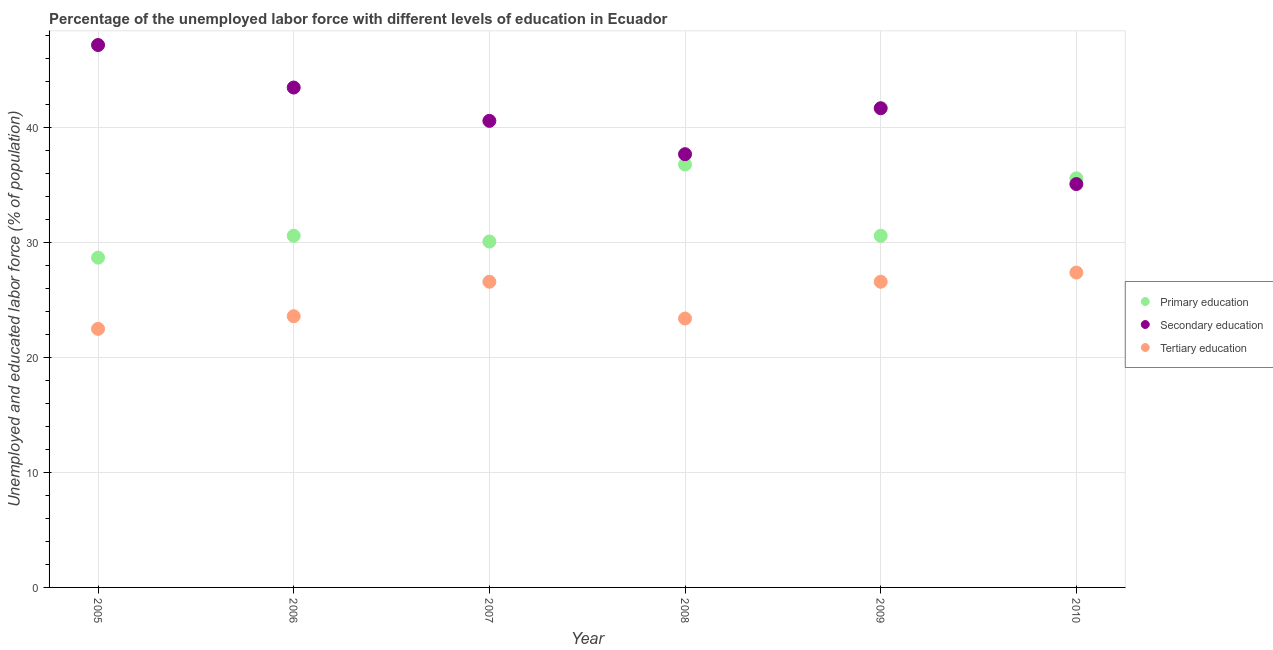Is the number of dotlines equal to the number of legend labels?
Provide a short and direct response. Yes. What is the percentage of labor force who received tertiary education in 2005?
Provide a succinct answer. 22.5. Across all years, what is the maximum percentage of labor force who received tertiary education?
Your response must be concise. 27.4. Across all years, what is the minimum percentage of labor force who received tertiary education?
Provide a short and direct response. 22.5. In which year was the percentage of labor force who received secondary education minimum?
Provide a short and direct response. 2010. What is the total percentage of labor force who received tertiary education in the graph?
Your answer should be very brief. 150.1. What is the difference between the percentage of labor force who received tertiary education in 2005 and that in 2008?
Provide a short and direct response. -0.9. What is the difference between the percentage of labor force who received primary education in 2006 and the percentage of labor force who received tertiary education in 2005?
Provide a succinct answer. 8.1. What is the average percentage of labor force who received tertiary education per year?
Offer a terse response. 25.02. In the year 2010, what is the difference between the percentage of labor force who received tertiary education and percentage of labor force who received primary education?
Provide a short and direct response. -8.2. In how many years, is the percentage of labor force who received tertiary education greater than 6 %?
Give a very brief answer. 6. What is the ratio of the percentage of labor force who received tertiary education in 2007 to that in 2010?
Your answer should be compact. 0.97. Is the percentage of labor force who received tertiary education in 2007 less than that in 2008?
Ensure brevity in your answer.  No. What is the difference between the highest and the second highest percentage of labor force who received tertiary education?
Make the answer very short. 0.8. What is the difference between the highest and the lowest percentage of labor force who received tertiary education?
Your response must be concise. 4.9. Is the sum of the percentage of labor force who received secondary education in 2007 and 2010 greater than the maximum percentage of labor force who received primary education across all years?
Provide a short and direct response. Yes. Is the percentage of labor force who received tertiary education strictly less than the percentage of labor force who received secondary education over the years?
Your answer should be very brief. Yes. What is the difference between two consecutive major ticks on the Y-axis?
Make the answer very short. 10. Are the values on the major ticks of Y-axis written in scientific E-notation?
Offer a very short reply. No. Does the graph contain any zero values?
Your answer should be very brief. No. Where does the legend appear in the graph?
Give a very brief answer. Center right. What is the title of the graph?
Your response must be concise. Percentage of the unemployed labor force with different levels of education in Ecuador. What is the label or title of the X-axis?
Ensure brevity in your answer.  Year. What is the label or title of the Y-axis?
Make the answer very short. Unemployed and educated labor force (% of population). What is the Unemployed and educated labor force (% of population) of Primary education in 2005?
Keep it short and to the point. 28.7. What is the Unemployed and educated labor force (% of population) of Secondary education in 2005?
Provide a succinct answer. 47.2. What is the Unemployed and educated labor force (% of population) in Tertiary education in 2005?
Ensure brevity in your answer.  22.5. What is the Unemployed and educated labor force (% of population) of Primary education in 2006?
Your answer should be very brief. 30.6. What is the Unemployed and educated labor force (% of population) in Secondary education in 2006?
Ensure brevity in your answer.  43.5. What is the Unemployed and educated labor force (% of population) in Tertiary education in 2006?
Provide a short and direct response. 23.6. What is the Unemployed and educated labor force (% of population) of Primary education in 2007?
Offer a terse response. 30.1. What is the Unemployed and educated labor force (% of population) of Secondary education in 2007?
Offer a terse response. 40.6. What is the Unemployed and educated labor force (% of population) in Tertiary education in 2007?
Offer a very short reply. 26.6. What is the Unemployed and educated labor force (% of population) in Primary education in 2008?
Your answer should be compact. 36.8. What is the Unemployed and educated labor force (% of population) of Secondary education in 2008?
Give a very brief answer. 37.7. What is the Unemployed and educated labor force (% of population) in Tertiary education in 2008?
Offer a terse response. 23.4. What is the Unemployed and educated labor force (% of population) of Primary education in 2009?
Provide a succinct answer. 30.6. What is the Unemployed and educated labor force (% of population) of Secondary education in 2009?
Your answer should be very brief. 41.7. What is the Unemployed and educated labor force (% of population) of Tertiary education in 2009?
Your answer should be very brief. 26.6. What is the Unemployed and educated labor force (% of population) in Primary education in 2010?
Offer a very short reply. 35.6. What is the Unemployed and educated labor force (% of population) of Secondary education in 2010?
Your answer should be compact. 35.1. What is the Unemployed and educated labor force (% of population) of Tertiary education in 2010?
Give a very brief answer. 27.4. Across all years, what is the maximum Unemployed and educated labor force (% of population) in Primary education?
Offer a terse response. 36.8. Across all years, what is the maximum Unemployed and educated labor force (% of population) in Secondary education?
Provide a short and direct response. 47.2. Across all years, what is the maximum Unemployed and educated labor force (% of population) in Tertiary education?
Provide a short and direct response. 27.4. Across all years, what is the minimum Unemployed and educated labor force (% of population) of Primary education?
Your answer should be very brief. 28.7. Across all years, what is the minimum Unemployed and educated labor force (% of population) in Secondary education?
Make the answer very short. 35.1. Across all years, what is the minimum Unemployed and educated labor force (% of population) in Tertiary education?
Keep it short and to the point. 22.5. What is the total Unemployed and educated labor force (% of population) of Primary education in the graph?
Offer a very short reply. 192.4. What is the total Unemployed and educated labor force (% of population) in Secondary education in the graph?
Offer a terse response. 245.8. What is the total Unemployed and educated labor force (% of population) in Tertiary education in the graph?
Provide a short and direct response. 150.1. What is the difference between the Unemployed and educated labor force (% of population) in Primary education in 2005 and that in 2006?
Offer a very short reply. -1.9. What is the difference between the Unemployed and educated labor force (% of population) in Secondary education in 2005 and that in 2007?
Keep it short and to the point. 6.6. What is the difference between the Unemployed and educated labor force (% of population) of Tertiary education in 2005 and that in 2007?
Your answer should be very brief. -4.1. What is the difference between the Unemployed and educated labor force (% of population) in Primary education in 2005 and that in 2008?
Offer a terse response. -8.1. What is the difference between the Unemployed and educated labor force (% of population) of Secondary education in 2005 and that in 2008?
Make the answer very short. 9.5. What is the difference between the Unemployed and educated labor force (% of population) of Tertiary education in 2005 and that in 2008?
Offer a very short reply. -0.9. What is the difference between the Unemployed and educated labor force (% of population) in Primary education in 2005 and that in 2009?
Offer a very short reply. -1.9. What is the difference between the Unemployed and educated labor force (% of population) of Tertiary education in 2005 and that in 2009?
Your response must be concise. -4.1. What is the difference between the Unemployed and educated labor force (% of population) in Primary education in 2005 and that in 2010?
Give a very brief answer. -6.9. What is the difference between the Unemployed and educated labor force (% of population) of Secondary education in 2005 and that in 2010?
Provide a succinct answer. 12.1. What is the difference between the Unemployed and educated labor force (% of population) in Primary education in 2006 and that in 2007?
Your answer should be very brief. 0.5. What is the difference between the Unemployed and educated labor force (% of population) of Secondary education in 2006 and that in 2007?
Offer a terse response. 2.9. What is the difference between the Unemployed and educated labor force (% of population) of Tertiary education in 2006 and that in 2007?
Provide a short and direct response. -3. What is the difference between the Unemployed and educated labor force (% of population) of Primary education in 2006 and that in 2008?
Provide a short and direct response. -6.2. What is the difference between the Unemployed and educated labor force (% of population) of Secondary education in 2006 and that in 2009?
Your answer should be very brief. 1.8. What is the difference between the Unemployed and educated labor force (% of population) of Primary education in 2006 and that in 2010?
Offer a very short reply. -5. What is the difference between the Unemployed and educated labor force (% of population) of Tertiary education in 2006 and that in 2010?
Your answer should be very brief. -3.8. What is the difference between the Unemployed and educated labor force (% of population) in Primary education in 2007 and that in 2008?
Your response must be concise. -6.7. What is the difference between the Unemployed and educated labor force (% of population) in Primary education in 2007 and that in 2010?
Your response must be concise. -5.5. What is the difference between the Unemployed and educated labor force (% of population) of Secondary education in 2007 and that in 2010?
Provide a succinct answer. 5.5. What is the difference between the Unemployed and educated labor force (% of population) of Primary education in 2008 and that in 2009?
Ensure brevity in your answer.  6.2. What is the difference between the Unemployed and educated labor force (% of population) of Secondary education in 2008 and that in 2009?
Provide a succinct answer. -4. What is the difference between the Unemployed and educated labor force (% of population) in Tertiary education in 2008 and that in 2009?
Your response must be concise. -3.2. What is the difference between the Unemployed and educated labor force (% of population) of Primary education in 2009 and that in 2010?
Keep it short and to the point. -5. What is the difference between the Unemployed and educated labor force (% of population) in Tertiary education in 2009 and that in 2010?
Offer a very short reply. -0.8. What is the difference between the Unemployed and educated labor force (% of population) in Primary education in 2005 and the Unemployed and educated labor force (% of population) in Secondary education in 2006?
Ensure brevity in your answer.  -14.8. What is the difference between the Unemployed and educated labor force (% of population) of Primary education in 2005 and the Unemployed and educated labor force (% of population) of Tertiary education in 2006?
Provide a succinct answer. 5.1. What is the difference between the Unemployed and educated labor force (% of population) in Secondary education in 2005 and the Unemployed and educated labor force (% of population) in Tertiary education in 2006?
Provide a short and direct response. 23.6. What is the difference between the Unemployed and educated labor force (% of population) in Primary education in 2005 and the Unemployed and educated labor force (% of population) in Secondary education in 2007?
Offer a very short reply. -11.9. What is the difference between the Unemployed and educated labor force (% of population) of Primary education in 2005 and the Unemployed and educated labor force (% of population) of Tertiary education in 2007?
Your response must be concise. 2.1. What is the difference between the Unemployed and educated labor force (% of population) in Secondary education in 2005 and the Unemployed and educated labor force (% of population) in Tertiary education in 2007?
Provide a succinct answer. 20.6. What is the difference between the Unemployed and educated labor force (% of population) of Primary education in 2005 and the Unemployed and educated labor force (% of population) of Secondary education in 2008?
Offer a very short reply. -9. What is the difference between the Unemployed and educated labor force (% of population) of Secondary education in 2005 and the Unemployed and educated labor force (% of population) of Tertiary education in 2008?
Give a very brief answer. 23.8. What is the difference between the Unemployed and educated labor force (% of population) in Secondary education in 2005 and the Unemployed and educated labor force (% of population) in Tertiary education in 2009?
Give a very brief answer. 20.6. What is the difference between the Unemployed and educated labor force (% of population) of Primary education in 2005 and the Unemployed and educated labor force (% of population) of Tertiary education in 2010?
Your response must be concise. 1.3. What is the difference between the Unemployed and educated labor force (% of population) of Secondary education in 2005 and the Unemployed and educated labor force (% of population) of Tertiary education in 2010?
Provide a succinct answer. 19.8. What is the difference between the Unemployed and educated labor force (% of population) of Primary education in 2006 and the Unemployed and educated labor force (% of population) of Secondary education in 2007?
Offer a terse response. -10. What is the difference between the Unemployed and educated labor force (% of population) in Primary education in 2006 and the Unemployed and educated labor force (% of population) in Secondary education in 2008?
Offer a very short reply. -7.1. What is the difference between the Unemployed and educated labor force (% of population) in Secondary education in 2006 and the Unemployed and educated labor force (% of population) in Tertiary education in 2008?
Make the answer very short. 20.1. What is the difference between the Unemployed and educated labor force (% of population) in Secondary education in 2006 and the Unemployed and educated labor force (% of population) in Tertiary education in 2009?
Provide a short and direct response. 16.9. What is the difference between the Unemployed and educated labor force (% of population) in Secondary education in 2006 and the Unemployed and educated labor force (% of population) in Tertiary education in 2010?
Provide a succinct answer. 16.1. What is the difference between the Unemployed and educated labor force (% of population) in Secondary education in 2007 and the Unemployed and educated labor force (% of population) in Tertiary education in 2008?
Offer a terse response. 17.2. What is the difference between the Unemployed and educated labor force (% of population) in Primary education in 2007 and the Unemployed and educated labor force (% of population) in Secondary education in 2009?
Offer a terse response. -11.6. What is the difference between the Unemployed and educated labor force (% of population) in Primary education in 2007 and the Unemployed and educated labor force (% of population) in Tertiary education in 2009?
Your response must be concise. 3.5. What is the difference between the Unemployed and educated labor force (% of population) in Secondary education in 2007 and the Unemployed and educated labor force (% of population) in Tertiary education in 2009?
Provide a succinct answer. 14. What is the difference between the Unemployed and educated labor force (% of population) of Primary education in 2007 and the Unemployed and educated labor force (% of population) of Secondary education in 2010?
Make the answer very short. -5. What is the difference between the Unemployed and educated labor force (% of population) of Primary education in 2008 and the Unemployed and educated labor force (% of population) of Secondary education in 2009?
Your answer should be very brief. -4.9. What is the difference between the Unemployed and educated labor force (% of population) in Primary education in 2008 and the Unemployed and educated labor force (% of population) in Tertiary education in 2009?
Keep it short and to the point. 10.2. What is the difference between the Unemployed and educated labor force (% of population) of Primary education in 2008 and the Unemployed and educated labor force (% of population) of Tertiary education in 2010?
Offer a terse response. 9.4. What is the difference between the Unemployed and educated labor force (% of population) of Primary education in 2009 and the Unemployed and educated labor force (% of population) of Tertiary education in 2010?
Keep it short and to the point. 3.2. What is the average Unemployed and educated labor force (% of population) in Primary education per year?
Your answer should be compact. 32.07. What is the average Unemployed and educated labor force (% of population) of Secondary education per year?
Your answer should be very brief. 40.97. What is the average Unemployed and educated labor force (% of population) in Tertiary education per year?
Keep it short and to the point. 25.02. In the year 2005, what is the difference between the Unemployed and educated labor force (% of population) in Primary education and Unemployed and educated labor force (% of population) in Secondary education?
Ensure brevity in your answer.  -18.5. In the year 2005, what is the difference between the Unemployed and educated labor force (% of population) in Secondary education and Unemployed and educated labor force (% of population) in Tertiary education?
Your response must be concise. 24.7. In the year 2007, what is the difference between the Unemployed and educated labor force (% of population) of Primary education and Unemployed and educated labor force (% of population) of Secondary education?
Your response must be concise. -10.5. In the year 2007, what is the difference between the Unemployed and educated labor force (% of population) of Primary education and Unemployed and educated labor force (% of population) of Tertiary education?
Give a very brief answer. 3.5. In the year 2008, what is the difference between the Unemployed and educated labor force (% of population) of Primary education and Unemployed and educated labor force (% of population) of Tertiary education?
Ensure brevity in your answer.  13.4. In the year 2008, what is the difference between the Unemployed and educated labor force (% of population) of Secondary education and Unemployed and educated labor force (% of population) of Tertiary education?
Offer a terse response. 14.3. In the year 2009, what is the difference between the Unemployed and educated labor force (% of population) in Primary education and Unemployed and educated labor force (% of population) in Secondary education?
Provide a succinct answer. -11.1. In the year 2009, what is the difference between the Unemployed and educated labor force (% of population) of Secondary education and Unemployed and educated labor force (% of population) of Tertiary education?
Make the answer very short. 15.1. In the year 2010, what is the difference between the Unemployed and educated labor force (% of population) of Primary education and Unemployed and educated labor force (% of population) of Tertiary education?
Ensure brevity in your answer.  8.2. What is the ratio of the Unemployed and educated labor force (% of population) in Primary education in 2005 to that in 2006?
Keep it short and to the point. 0.94. What is the ratio of the Unemployed and educated labor force (% of population) of Secondary education in 2005 to that in 2006?
Ensure brevity in your answer.  1.09. What is the ratio of the Unemployed and educated labor force (% of population) in Tertiary education in 2005 to that in 2006?
Your answer should be very brief. 0.95. What is the ratio of the Unemployed and educated labor force (% of population) in Primary education in 2005 to that in 2007?
Offer a terse response. 0.95. What is the ratio of the Unemployed and educated labor force (% of population) in Secondary education in 2005 to that in 2007?
Your answer should be compact. 1.16. What is the ratio of the Unemployed and educated labor force (% of population) of Tertiary education in 2005 to that in 2007?
Your response must be concise. 0.85. What is the ratio of the Unemployed and educated labor force (% of population) of Primary education in 2005 to that in 2008?
Provide a short and direct response. 0.78. What is the ratio of the Unemployed and educated labor force (% of population) of Secondary education in 2005 to that in 2008?
Give a very brief answer. 1.25. What is the ratio of the Unemployed and educated labor force (% of population) of Tertiary education in 2005 to that in 2008?
Provide a short and direct response. 0.96. What is the ratio of the Unemployed and educated labor force (% of population) in Primary education in 2005 to that in 2009?
Offer a terse response. 0.94. What is the ratio of the Unemployed and educated labor force (% of population) in Secondary education in 2005 to that in 2009?
Offer a terse response. 1.13. What is the ratio of the Unemployed and educated labor force (% of population) of Tertiary education in 2005 to that in 2009?
Offer a very short reply. 0.85. What is the ratio of the Unemployed and educated labor force (% of population) of Primary education in 2005 to that in 2010?
Offer a very short reply. 0.81. What is the ratio of the Unemployed and educated labor force (% of population) in Secondary education in 2005 to that in 2010?
Your response must be concise. 1.34. What is the ratio of the Unemployed and educated labor force (% of population) of Tertiary education in 2005 to that in 2010?
Your response must be concise. 0.82. What is the ratio of the Unemployed and educated labor force (% of population) in Primary education in 2006 to that in 2007?
Offer a terse response. 1.02. What is the ratio of the Unemployed and educated labor force (% of population) in Secondary education in 2006 to that in 2007?
Your answer should be very brief. 1.07. What is the ratio of the Unemployed and educated labor force (% of population) of Tertiary education in 2006 to that in 2007?
Make the answer very short. 0.89. What is the ratio of the Unemployed and educated labor force (% of population) in Primary education in 2006 to that in 2008?
Offer a very short reply. 0.83. What is the ratio of the Unemployed and educated labor force (% of population) of Secondary education in 2006 to that in 2008?
Ensure brevity in your answer.  1.15. What is the ratio of the Unemployed and educated labor force (% of population) of Tertiary education in 2006 to that in 2008?
Provide a short and direct response. 1.01. What is the ratio of the Unemployed and educated labor force (% of population) in Primary education in 2006 to that in 2009?
Provide a succinct answer. 1. What is the ratio of the Unemployed and educated labor force (% of population) in Secondary education in 2006 to that in 2009?
Your answer should be compact. 1.04. What is the ratio of the Unemployed and educated labor force (% of population) in Tertiary education in 2006 to that in 2009?
Provide a succinct answer. 0.89. What is the ratio of the Unemployed and educated labor force (% of population) of Primary education in 2006 to that in 2010?
Your response must be concise. 0.86. What is the ratio of the Unemployed and educated labor force (% of population) of Secondary education in 2006 to that in 2010?
Your answer should be compact. 1.24. What is the ratio of the Unemployed and educated labor force (% of population) of Tertiary education in 2006 to that in 2010?
Offer a terse response. 0.86. What is the ratio of the Unemployed and educated labor force (% of population) in Primary education in 2007 to that in 2008?
Provide a succinct answer. 0.82. What is the ratio of the Unemployed and educated labor force (% of population) in Secondary education in 2007 to that in 2008?
Make the answer very short. 1.08. What is the ratio of the Unemployed and educated labor force (% of population) in Tertiary education in 2007 to that in 2008?
Provide a short and direct response. 1.14. What is the ratio of the Unemployed and educated labor force (% of population) in Primary education in 2007 to that in 2009?
Offer a terse response. 0.98. What is the ratio of the Unemployed and educated labor force (% of population) of Secondary education in 2007 to that in 2009?
Your response must be concise. 0.97. What is the ratio of the Unemployed and educated labor force (% of population) in Primary education in 2007 to that in 2010?
Make the answer very short. 0.85. What is the ratio of the Unemployed and educated labor force (% of population) of Secondary education in 2007 to that in 2010?
Your response must be concise. 1.16. What is the ratio of the Unemployed and educated labor force (% of population) of Tertiary education in 2007 to that in 2010?
Give a very brief answer. 0.97. What is the ratio of the Unemployed and educated labor force (% of population) in Primary education in 2008 to that in 2009?
Your answer should be very brief. 1.2. What is the ratio of the Unemployed and educated labor force (% of population) of Secondary education in 2008 to that in 2009?
Offer a terse response. 0.9. What is the ratio of the Unemployed and educated labor force (% of population) in Tertiary education in 2008 to that in 2009?
Your answer should be very brief. 0.88. What is the ratio of the Unemployed and educated labor force (% of population) of Primary education in 2008 to that in 2010?
Make the answer very short. 1.03. What is the ratio of the Unemployed and educated labor force (% of population) in Secondary education in 2008 to that in 2010?
Provide a succinct answer. 1.07. What is the ratio of the Unemployed and educated labor force (% of population) of Tertiary education in 2008 to that in 2010?
Your response must be concise. 0.85. What is the ratio of the Unemployed and educated labor force (% of population) in Primary education in 2009 to that in 2010?
Your answer should be compact. 0.86. What is the ratio of the Unemployed and educated labor force (% of population) in Secondary education in 2009 to that in 2010?
Provide a succinct answer. 1.19. What is the ratio of the Unemployed and educated labor force (% of population) in Tertiary education in 2009 to that in 2010?
Your response must be concise. 0.97. What is the difference between the highest and the second highest Unemployed and educated labor force (% of population) in Primary education?
Your answer should be compact. 1.2. What is the difference between the highest and the second highest Unemployed and educated labor force (% of population) in Secondary education?
Ensure brevity in your answer.  3.7. What is the difference between the highest and the lowest Unemployed and educated labor force (% of population) of Primary education?
Make the answer very short. 8.1. What is the difference between the highest and the lowest Unemployed and educated labor force (% of population) in Tertiary education?
Keep it short and to the point. 4.9. 